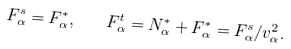Convert formula to latex. <formula><loc_0><loc_0><loc_500><loc_500>F _ { \alpha } ^ { s } = F ^ { * } _ { \alpha } , \quad F ^ { t } _ { \alpha } = N _ { \alpha } ^ { * } + F _ { \alpha } ^ { * } = F ^ { s } _ { \alpha } / v _ { \alpha } ^ { 2 } .</formula> 